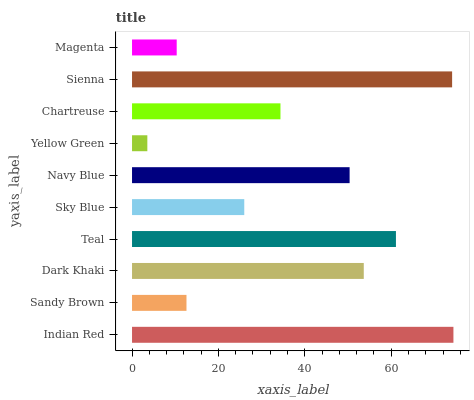Is Yellow Green the minimum?
Answer yes or no. Yes. Is Indian Red the maximum?
Answer yes or no. Yes. Is Sandy Brown the minimum?
Answer yes or no. No. Is Sandy Brown the maximum?
Answer yes or no. No. Is Indian Red greater than Sandy Brown?
Answer yes or no. Yes. Is Sandy Brown less than Indian Red?
Answer yes or no. Yes. Is Sandy Brown greater than Indian Red?
Answer yes or no. No. Is Indian Red less than Sandy Brown?
Answer yes or no. No. Is Navy Blue the high median?
Answer yes or no. Yes. Is Chartreuse the low median?
Answer yes or no. Yes. Is Chartreuse the high median?
Answer yes or no. No. Is Sky Blue the low median?
Answer yes or no. No. 